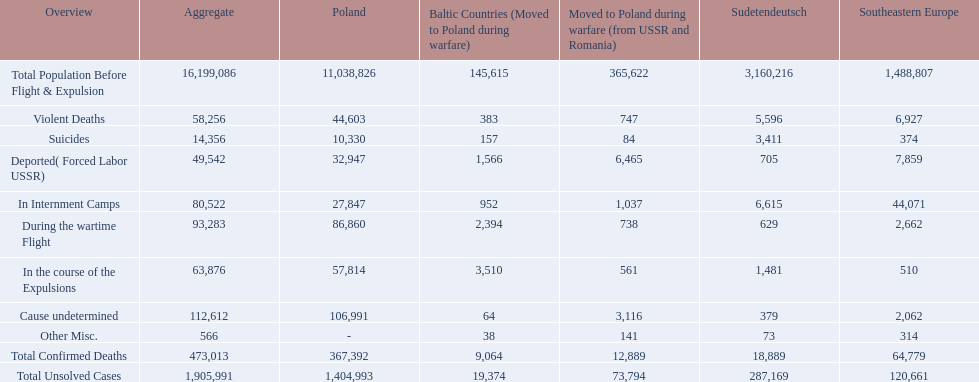Did any location have no violent deaths? No. 